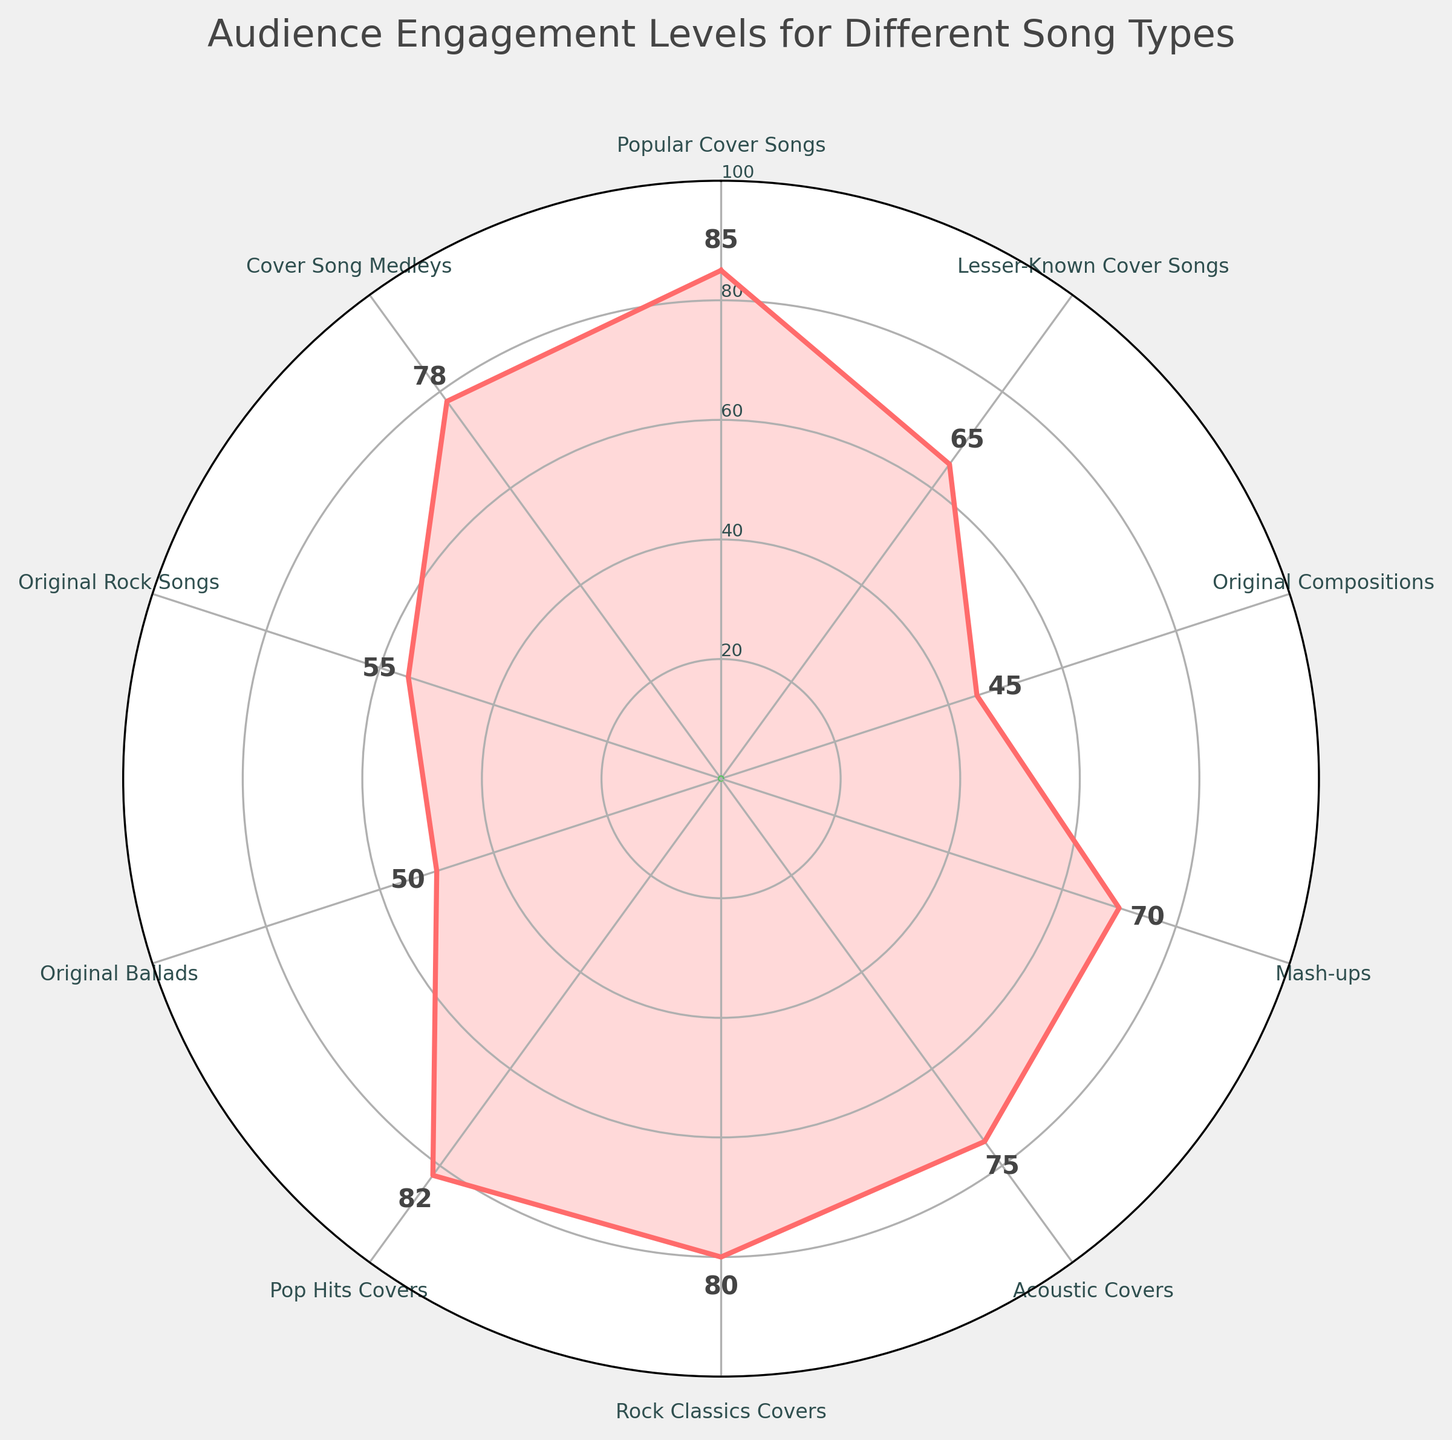What's the title of the plot? The title is usually located at the top of the plot, and in this case, it describes the subject of the figure.
Answer: Audience Engagement Levels for Different Song Types Which song type has the highest engagement level? The highest point on the gauge will indicate the highest engagement level. In the plot, "Popular Cover Songs" reaches the highest engagement level at the point labeled with 85.
Answer: Popular Cover Songs Which song type has the lowest engagement level? The lowest point on the gauge will indicate the lowest engagement level. The "Original Compositions" shows the lowest engagement level at 45.
Answer: Original Compositions What is the engagement level for Acoustic Covers? Find the label for "Acoustic Covers" in the plot and note down the corresponding value.
Answer: 75 Which song type has a higher engagement level: Original Ballads or Original Rock Songs? Locate "Original Ballads" and "Original Rock Songs" in the chart and compare their engagement levels. "Original Ballads" has 50 while "Original Rock Songs" has 55.
Answer: Original Rock Songs What's the average engagement level of all song types? Sum the engagement levels and divide by the number of song types: (85 + 65 + 45 + 70 + 75 + 80 + 82 + 50 + 55 + 78) / 10 = 68.
Answer: 68 Is the engagement level for Pop Hits Covers higher than Rock Classics Covers? Compare "Pop Hits Covers" and "Rock Classics Covers". "Pop Hits Covers" has an engagement level of 82, while "Rock Classics Covers" has 80.
Answer: Yes What is the engagement level range for all song types shown in the plot? The range is the difference between the highest and lowest engagement levels, which is 85 (Popular Cover Songs) - 45 (Original Compositions) = 40.
Answer: 40 Are there more cover songs or original compositions in the plot? Count the number of song types labeled as cover songs versus original compositions. There are more cover songs listed.
Answer: Cover Songs Which song type is closest in engagement level to the median value? Calculate the median of the engagement levels: 50, 55, 65, 70, 75, 78, 80, 82, 85 (median is 73). "Acoustic Covers" with an engagement level of 75 is closest to 73.
Answer: Acoustic Covers 